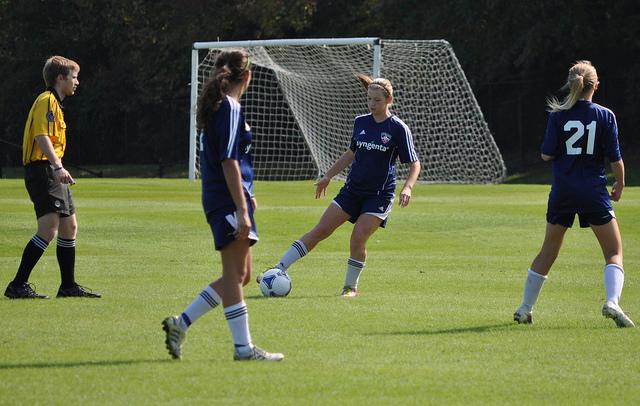What color is the net?
Give a very brief answer. White. How many people are pictured?
Keep it brief. 4. Where are the young women and men doing in the photo?
Give a very brief answer. Soccer. Are these girls or boys playing soccer?
Be succinct. Both. How many people are in the photo?
Write a very short answer. 4. 